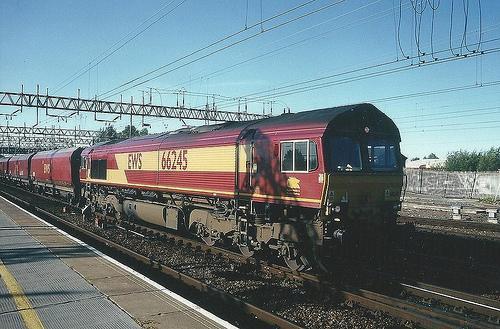How many trains are in the picture?
Give a very brief answer. 1. 